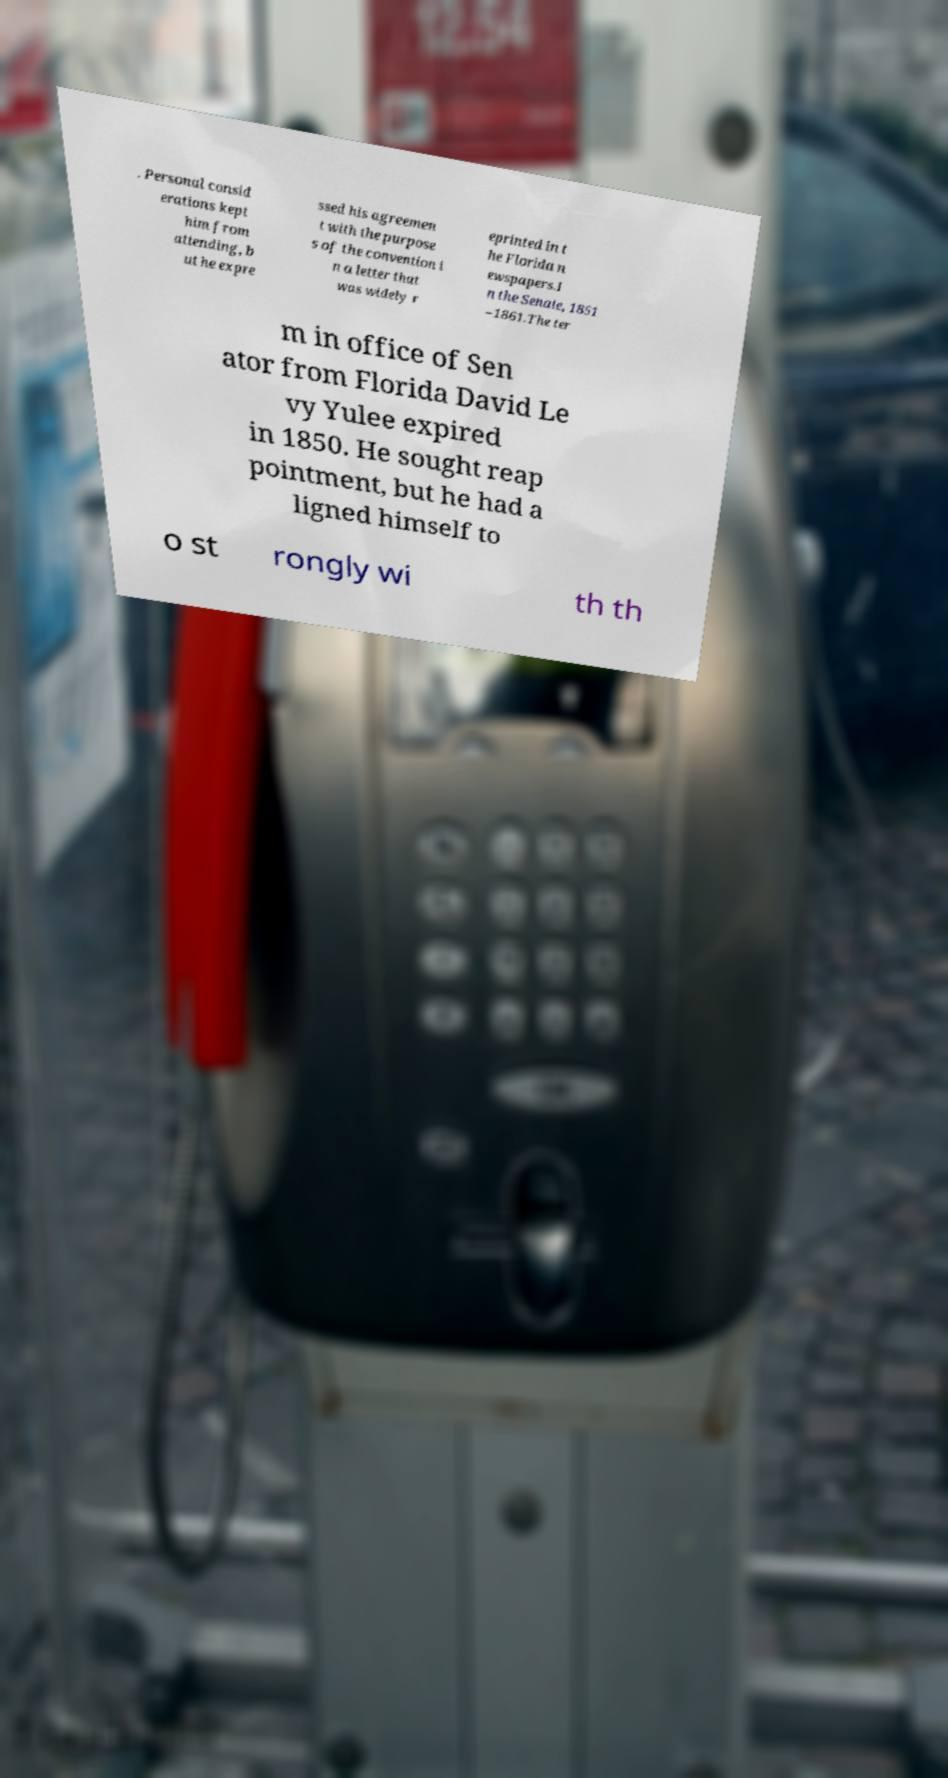Could you extract and type out the text from this image? . Personal consid erations kept him from attending, b ut he expre ssed his agreemen t with the purpose s of the convention i n a letter that was widely r eprinted in t he Florida n ewspapers.I n the Senate, 1851 –1861.The ter m in office of Sen ator from Florida David Le vy Yulee expired in 1850. He sought reap pointment, but he had a ligned himself to o st rongly wi th th 